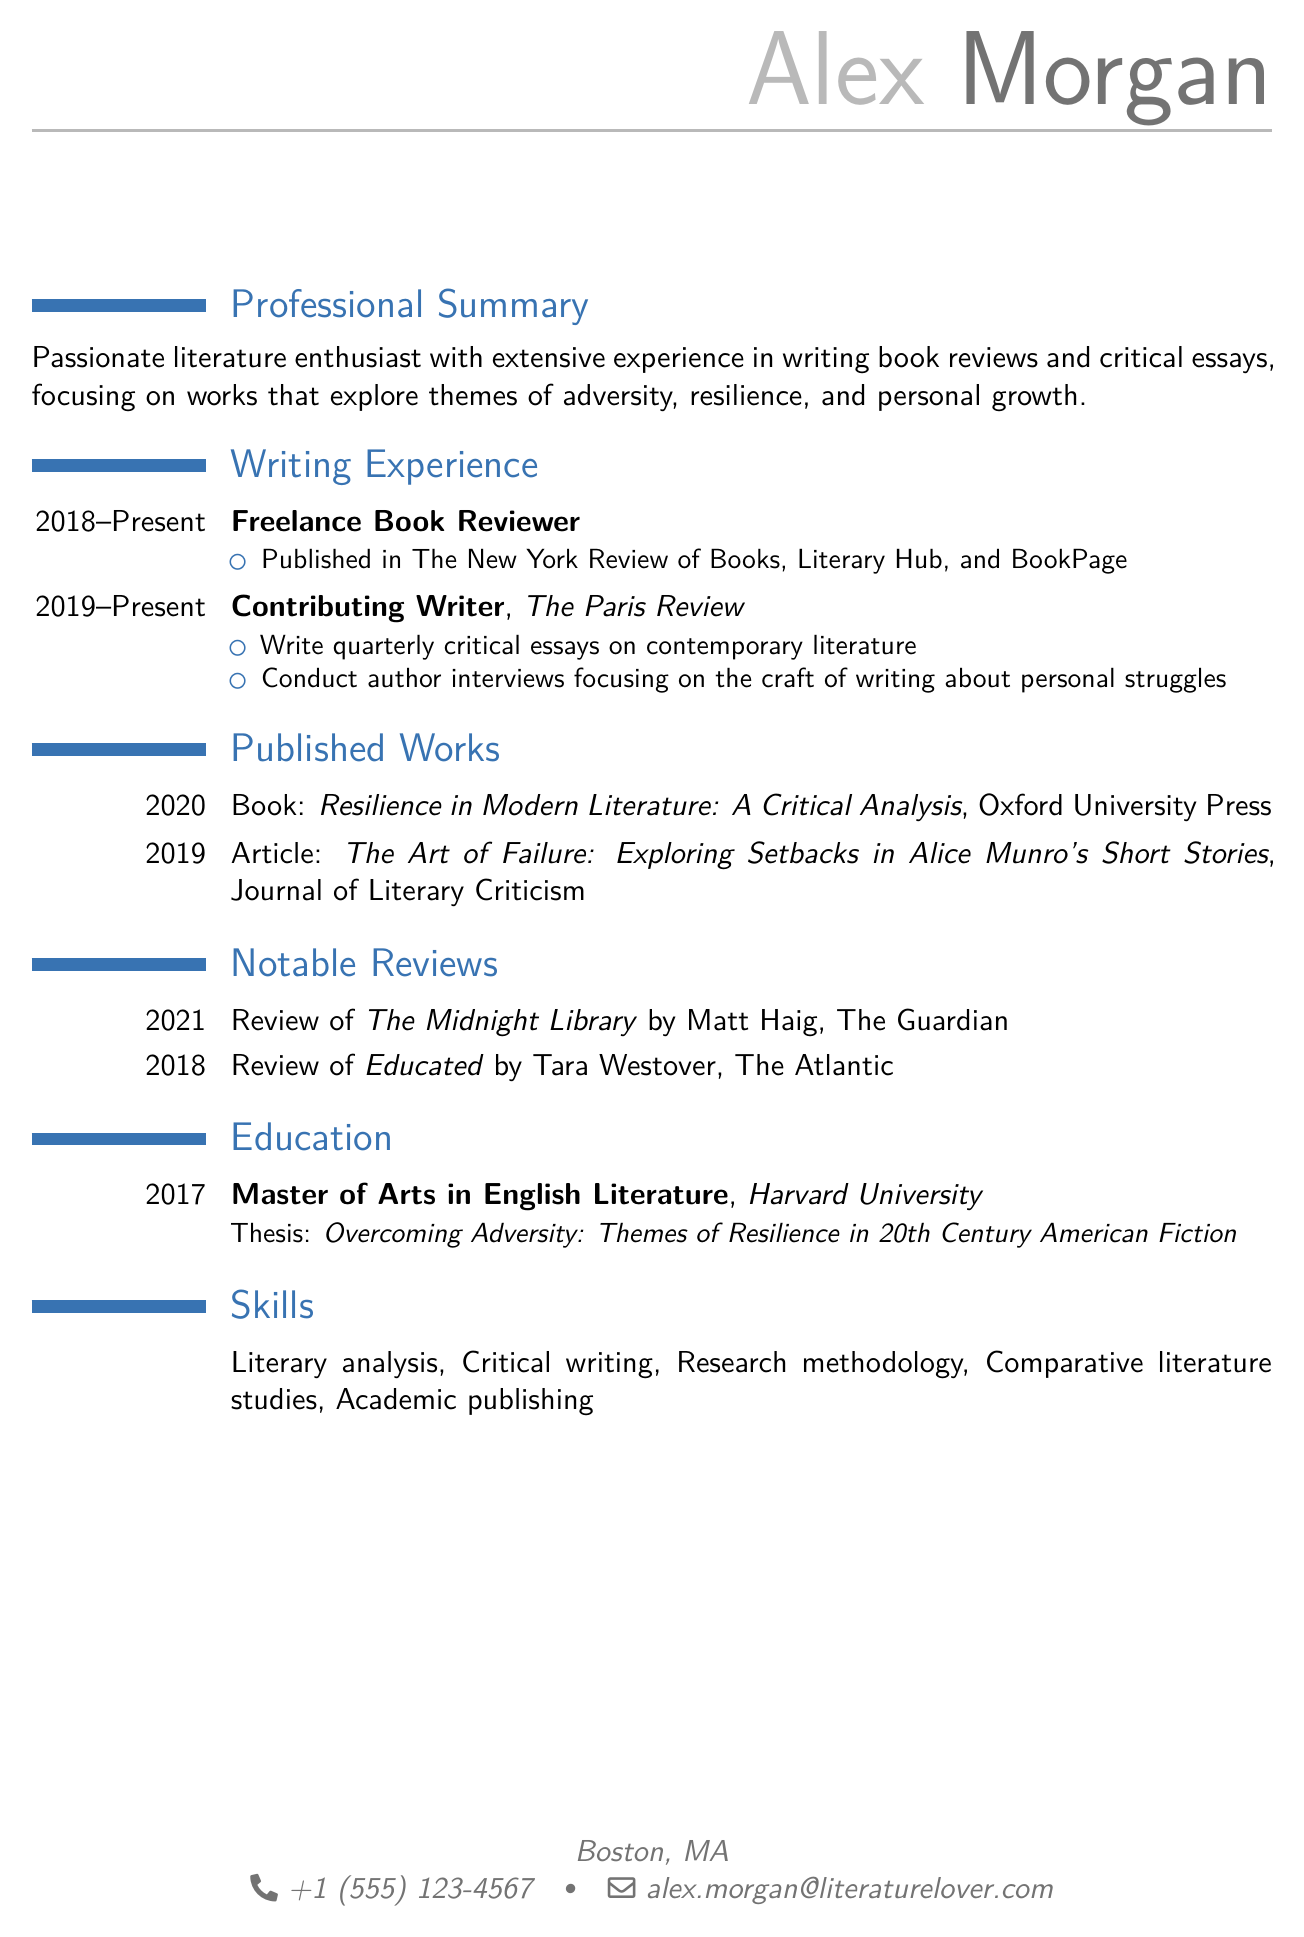what is the name of the author? The name of the author is presented in the personal info section of the document.
Answer: Alex Morgan what is the duration of Alex Morgan's freelance book reviewing experience? The duration mentioned for freelance book reviewing experience is from 2018 to Present.
Answer: 2018 - Present which institution did Alex Morgan attend for graduate studies? The education section specifies the institution where Alex Morgan earned a degree.
Answer: Harvard University what is the title of Alex Morgan's thesis? The thesis title is indicated under the education section of the document.
Answer: Overcoming Adversity: Themes of Resilience in 20th Century American Fiction how many notable reviews are listed in the document? The document states the number of notable reviews included under the notable reviews section.
Answer: 2 what type of writing experience does Alex Morgan have with The Paris Review? This question examines the specific role Alex Morgan has at The Paris Review, mentioned in the writing experience section.
Answer: Contributing Writer what is the publication year of the book "Resilience in Modern Literature: A Critical Analysis"? The year of publication is clearly listed in the published works section of the CV.
Answer: 2020 which publication featured a review of "The Midnight Library"? The document specifies where this review was published in the notable reviews section.
Answer: The Guardian what is the focus of Alex Morgan’s writing as stated in the professional summary? The professional summary provides insight into the central themes of Alex Morgan's writing.
Answer: Adversity, resilience, and personal growth 